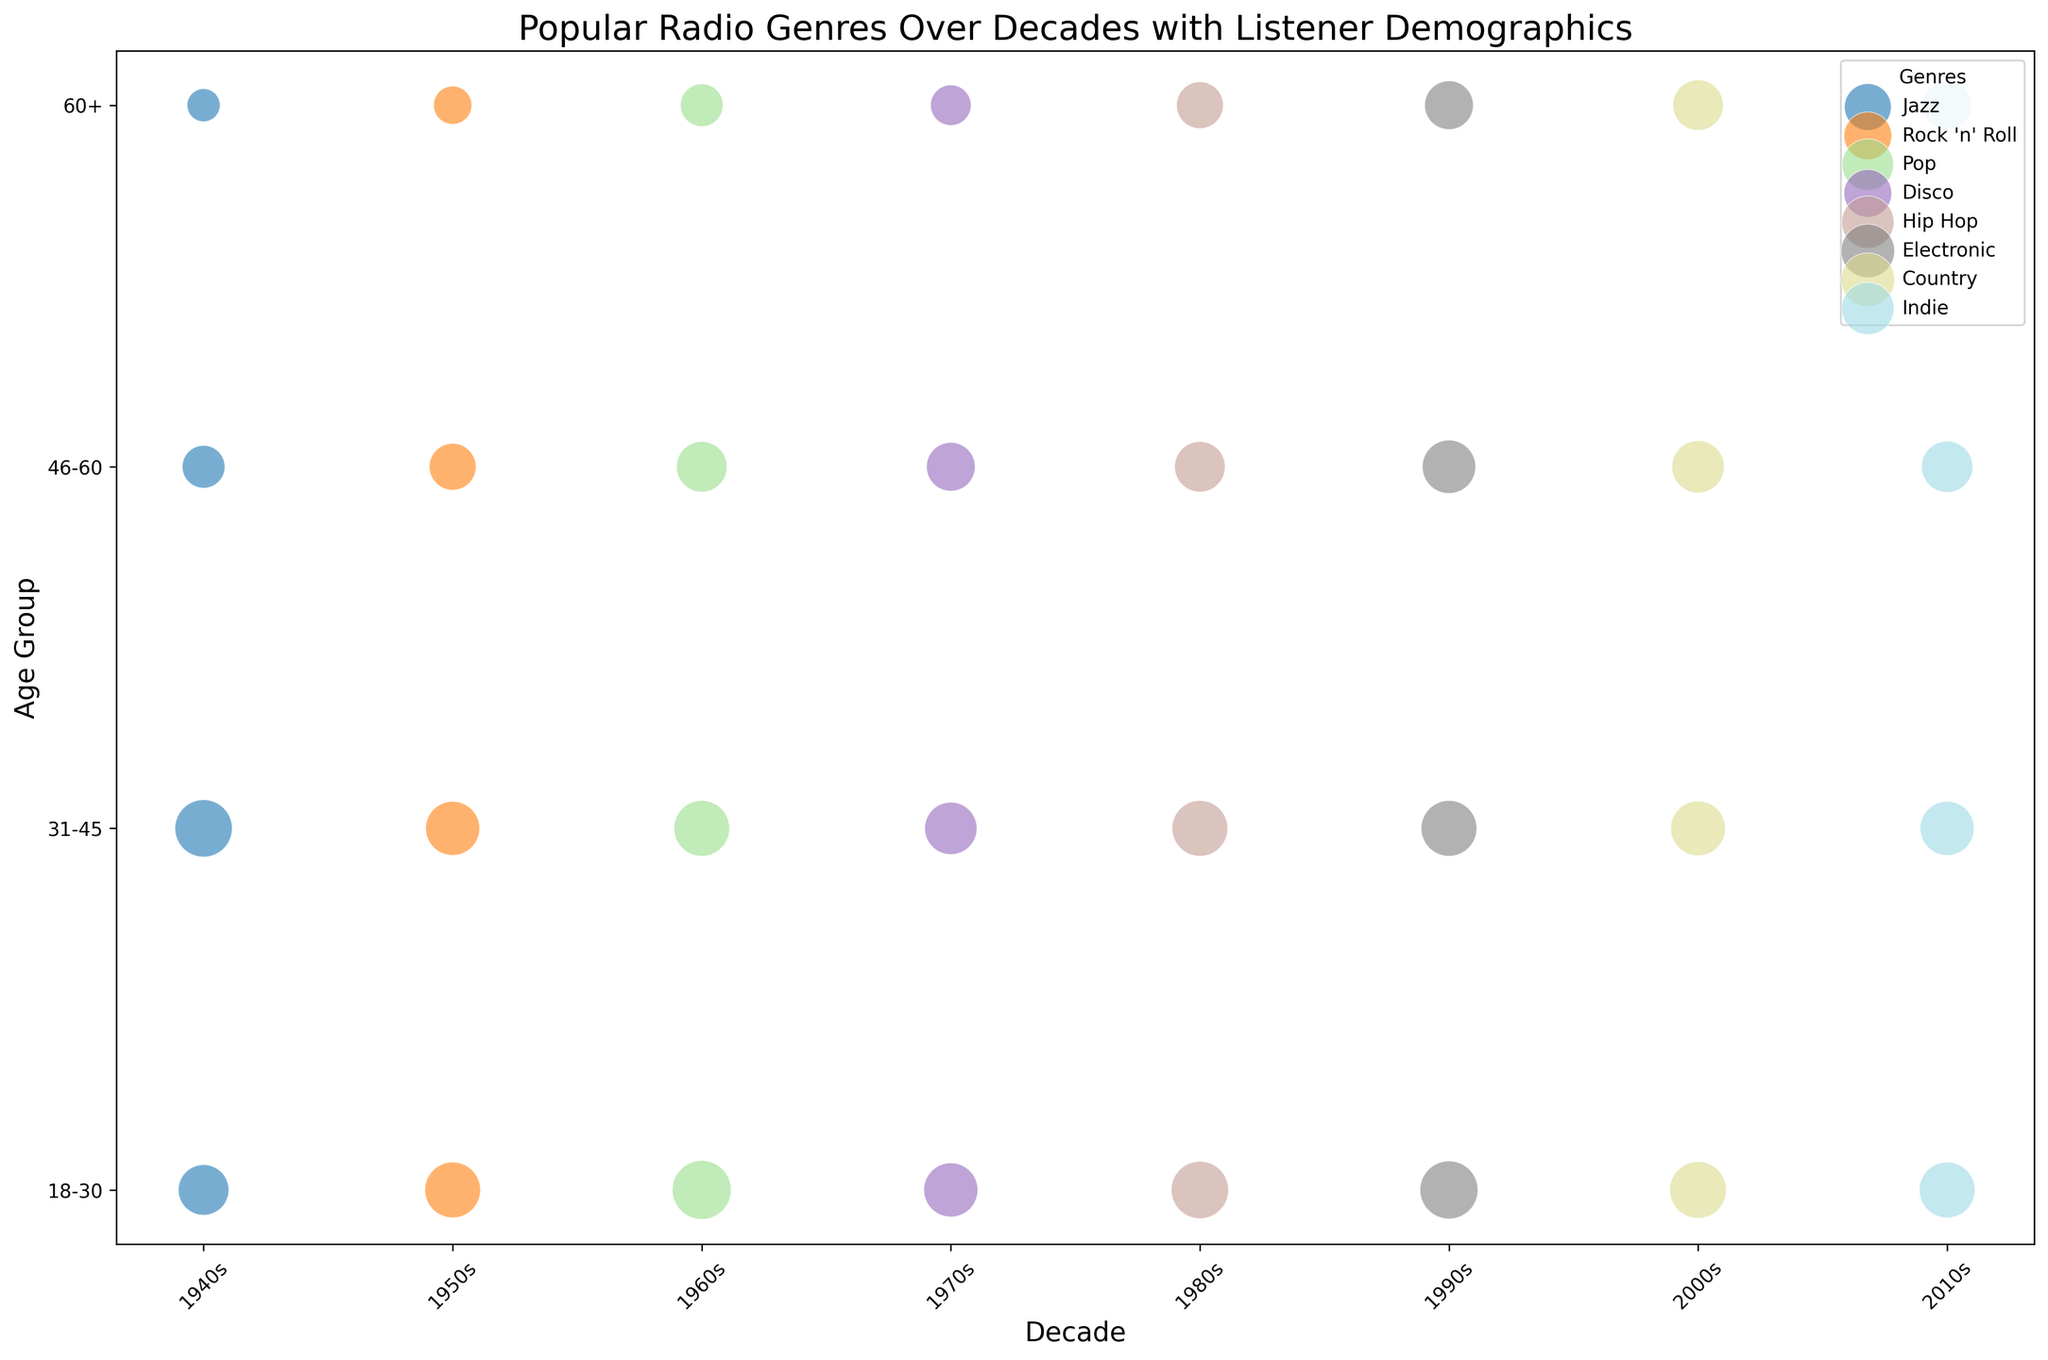What is the genre with the highest listener popularity among the 18-30 age group in the 1950s? In the figure, find the points representing the 1950s and identify the bubble corresponding to the 18-30 age group. Among these, locate the bubble with the largest size.
Answer: Rock 'n' Roll Which decade saw the largest number of listeners for the Pop genre in the 46-60 age group? Identify the bubbles representing the Pop genre and find those corresponding to the 46-60 age group. Then compare the y-axis values (number of listeners) among these data points across decades.
Answer: 1960s Compare the popularity of Jazz among listeners aged 31-45 in the 1940s with the popularity of Indie among the same age group in the 2010s. Which one is more popular? Locate the bubbles for Jazz in the 1940s and Indie in the 2010s, focusing on the 31-45 age group. Compare the size of these bubbles to determine which is larger, indicating greater popularity.
Answer: Jazz How many total listeners are there for the Country genre across all age groups in the 2000s? Identify the bubbles representing the Country genre in the 2000s across all age groups. Sum the y-axis values (number of listeners) for these bubbles.
Answer: 12,000,000 Which genre from the 1990s has the highest popularity among listeners aged 60+? Find the bubbles representing the 1990s and 60+ age group, then identify the genre with the largest bubble (indicating the highest popularity among this age group).
Answer: Electronic What is the average popularity of Disco among all age groups in the 1970s? Locate all the bubbles representing Disco in the 1970s, sum up their sizes (popularity), and divide by the number of age groups to find the average.
Answer: (80+75+65+45)/4 = 66.25 Discuss the trend in popularity for Hip Hop from the 1980s to the 1990s among the 31-45 age group. Has it increased or decreased? Compare the bubble sizes for Hip Hop in the 1980s and 1990s for the 31-45 age group to decide if the bubble has grown (increased popularity) or shrunk (decreased popularity).
Answer: Decreased Identify the genre from the 2010s with the lowest audience in the 60+ age group. Find the bubbles from the 2010s for the 60+ age group and identify the smallest bubble based on y-axis position (number of listeners).
Answer: Indie Which two genres had equal popularity among the 60+ age group in different decades, and in which decades did this occur? Find bubbles from different decades in the 60+ age group with equal sizes. Compare their sizes (popularity) and identify which genres and decades match.
Answer: Pop in 1960s and Electronic in 1990s (both have popularity of 65) Among the genres in the 1980s, which age group had the highest popularity for Hip Hop, and how does it compare to Electronic in the 1990s among the same age group? Identify the bubbles for Hip Hop in the 1980s and find the age group with the largest bubble size (highest popularity). Compare this value with the corresponding bubble for Electronic in the 1990s.
Answer: Hip Hop 1980s (18-30) vs. Electronic 1990s (18-30), Hip Hop is less popular than Electronic 